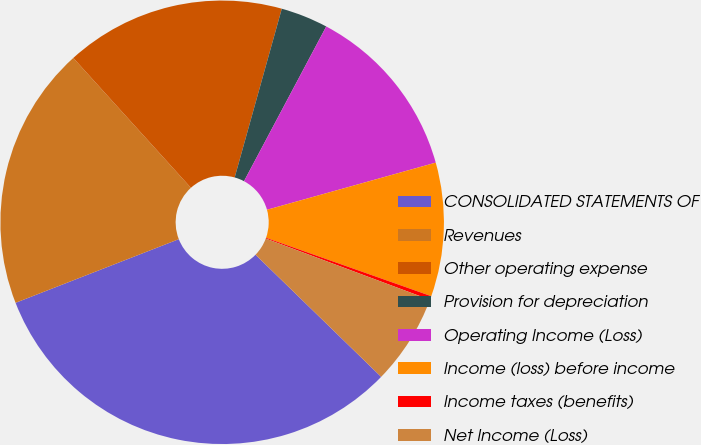Convert chart. <chart><loc_0><loc_0><loc_500><loc_500><pie_chart><fcel>CONSOLIDATED STATEMENTS OF<fcel>Revenues<fcel>Other operating expense<fcel>Provision for depreciation<fcel>Operating Income (Loss)<fcel>Income (loss) before income<fcel>Income taxes (benefits)<fcel>Net Income (Loss)<nl><fcel>31.81%<fcel>19.2%<fcel>16.05%<fcel>3.44%<fcel>12.89%<fcel>9.74%<fcel>0.28%<fcel>6.59%<nl></chart> 